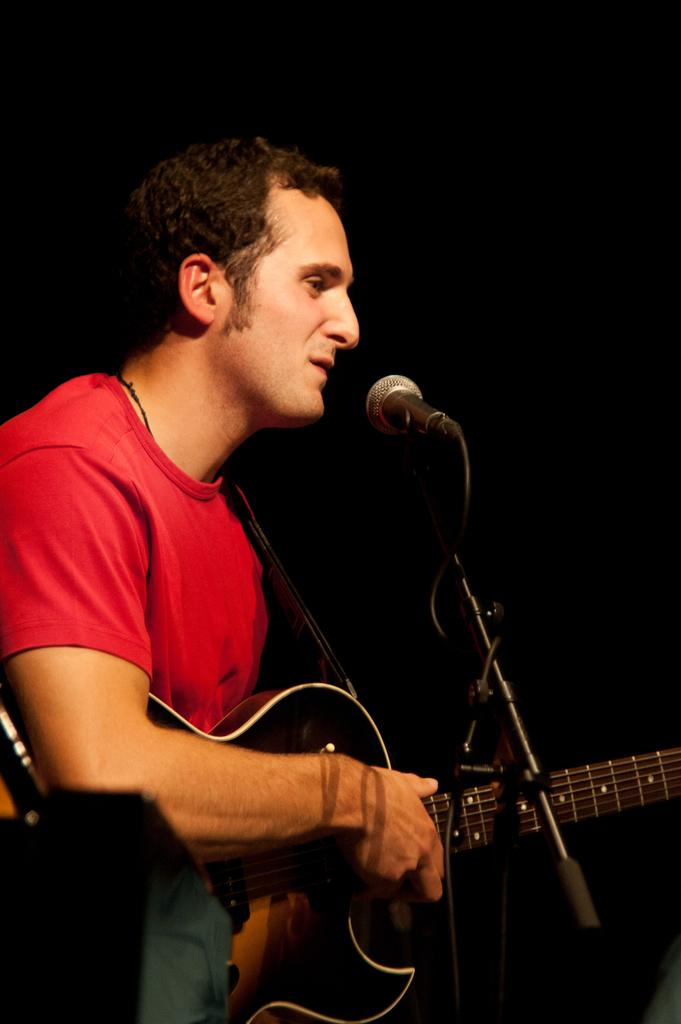Who is the main subject in the image? There is a man in the image. Where is the man located in the image? The man is on the left side of the image. What is the man wearing in the image? The man is wearing a red t-shirt. What object is the man holding in the image? The man is holding a guitar. What other object can be seen in the middle of the image? There is a microphone in the middle of the image. What type of animal is depicted on the door in the image? There is no door present in the image, and therefore no animal can be depicted on it. 